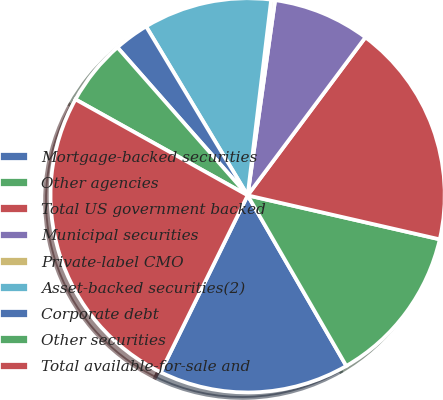<chart> <loc_0><loc_0><loc_500><loc_500><pie_chart><fcel>Mortgage-backed securities<fcel>Other agencies<fcel>Total US government backed<fcel>Municipal securities<fcel>Private-label CMO<fcel>Asset-backed securities(2)<fcel>Corporate debt<fcel>Other securities<fcel>Total available-for-sale and<nl><fcel>15.62%<fcel>13.07%<fcel>18.39%<fcel>7.97%<fcel>0.32%<fcel>10.52%<fcel>2.87%<fcel>5.42%<fcel>25.82%<nl></chart> 